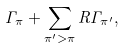<formula> <loc_0><loc_0><loc_500><loc_500>\Gamma _ { \pi } + \sum _ { \pi ^ { \prime } > \pi } R \Gamma _ { \pi ^ { \prime } } ,</formula> 